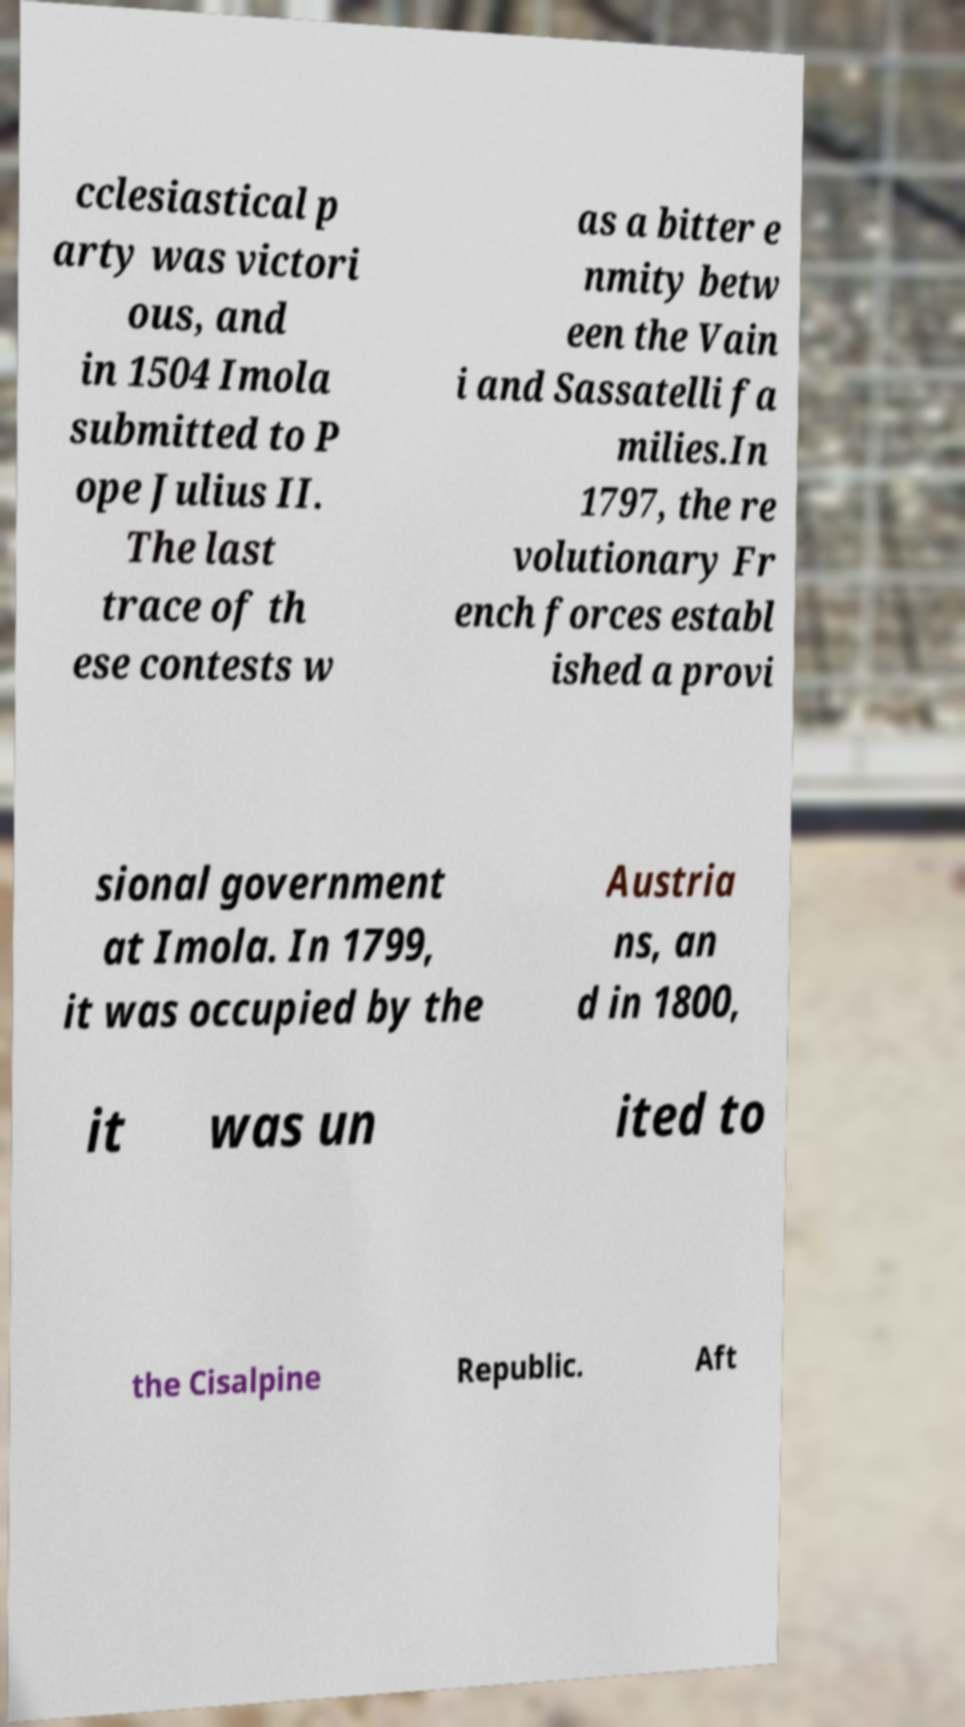There's text embedded in this image that I need extracted. Can you transcribe it verbatim? cclesiastical p arty was victori ous, and in 1504 Imola submitted to P ope Julius II. The last trace of th ese contests w as a bitter e nmity betw een the Vain i and Sassatelli fa milies.In 1797, the re volutionary Fr ench forces establ ished a provi sional government at Imola. In 1799, it was occupied by the Austria ns, an d in 1800, it was un ited to the Cisalpine Republic. Aft 